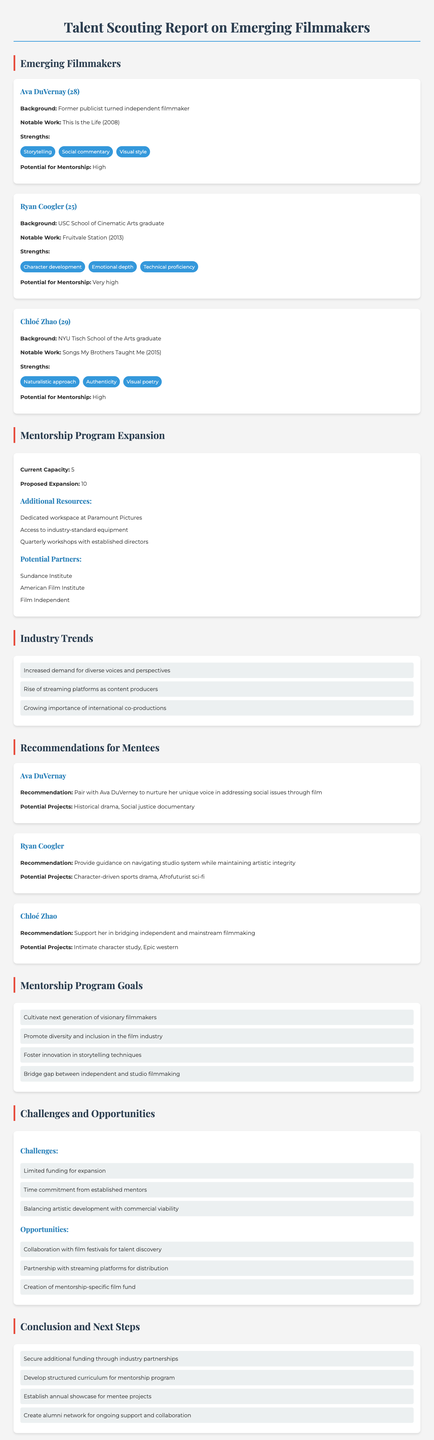What is the name of the first emerging filmmaker listed? The first emerging filmmaker listed in the report is Ava DuVernay.
Answer: Ava DuVernay How many emerging filmmakers are identified in the report? The report identifies three emerging filmmakers.
Answer: Three What is Ryan Coogler's notable work? Ryan Coogler's notable work mentioned in the document is Fruitvale Station.
Answer: Fruitvale Station What is the proposed expansion of the mentorship program? The proposed expansion of the mentorship program is to increase the capacity to ten mentees.
Answer: Ten What is one of the challenges mentioned in the document? One of the challenges mentioned in the document is limited funding for expansion.
Answer: Limited funding for expansion Which organization is listed as a potential partner for the mentorship program? Sundance Institute is listed as one of the potential partners for the mentorship program.
Answer: Sundance Institute What strength is highlighted for Chloé Zhao? Chloé Zhao's highlighted strength is her naturalistic approach.
Answer: Naturalistic approach What is one of the goals of the mentorship program? One of the goals of the mentorship program is to promote diversity and inclusion in the film industry.
Answer: Promote diversity and inclusion in the film industry What is a potential project for Ava DuVernay? A potential project for Ava DuVernay is a historical drama.
Answer: Historical drama 